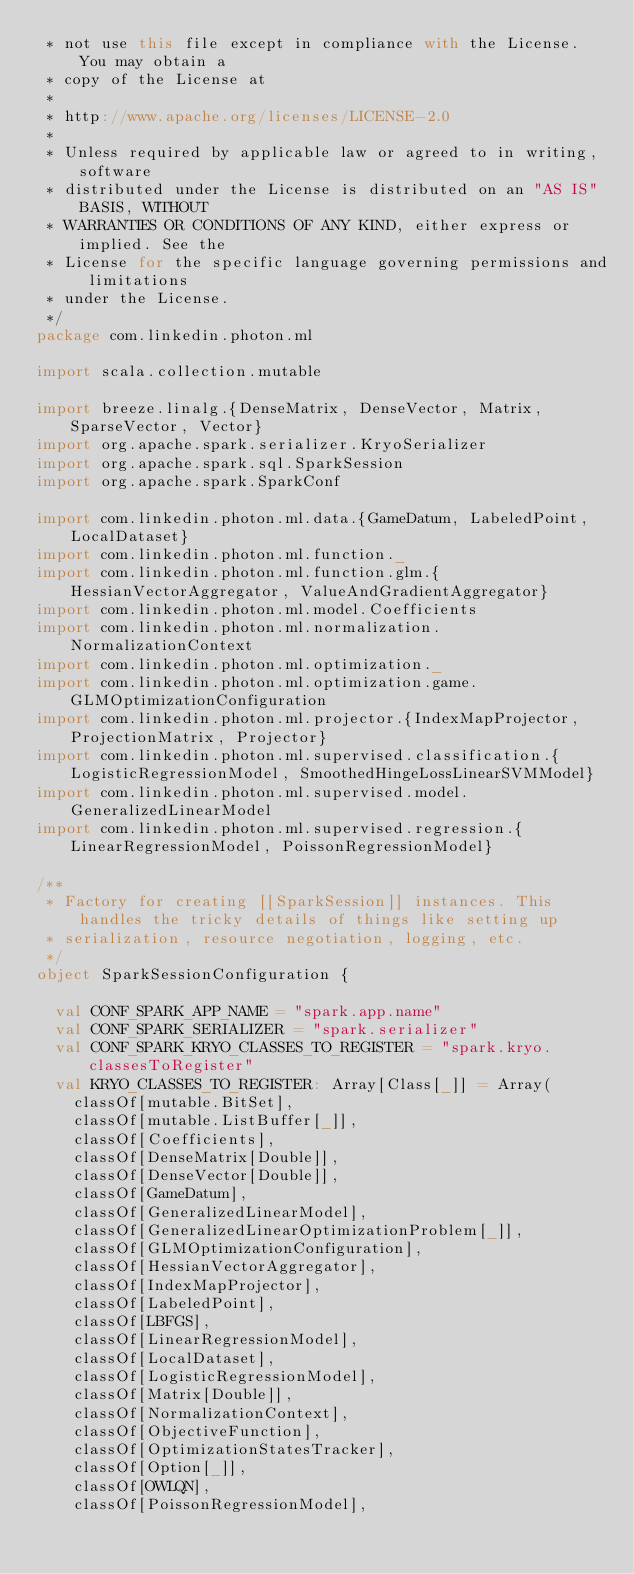<code> <loc_0><loc_0><loc_500><loc_500><_Scala_> * not use this file except in compliance with the License. You may obtain a
 * copy of the License at
 *
 * http://www.apache.org/licenses/LICENSE-2.0
 *
 * Unless required by applicable law or agreed to in writing, software
 * distributed under the License is distributed on an "AS IS" BASIS, WITHOUT
 * WARRANTIES OR CONDITIONS OF ANY KIND, either express or implied. See the
 * License for the specific language governing permissions and limitations
 * under the License.
 */
package com.linkedin.photon.ml

import scala.collection.mutable

import breeze.linalg.{DenseMatrix, DenseVector, Matrix, SparseVector, Vector}
import org.apache.spark.serializer.KryoSerializer
import org.apache.spark.sql.SparkSession
import org.apache.spark.SparkConf

import com.linkedin.photon.ml.data.{GameDatum, LabeledPoint, LocalDataset}
import com.linkedin.photon.ml.function._
import com.linkedin.photon.ml.function.glm.{HessianVectorAggregator, ValueAndGradientAggregator}
import com.linkedin.photon.ml.model.Coefficients
import com.linkedin.photon.ml.normalization.NormalizationContext
import com.linkedin.photon.ml.optimization._
import com.linkedin.photon.ml.optimization.game.GLMOptimizationConfiguration
import com.linkedin.photon.ml.projector.{IndexMapProjector, ProjectionMatrix, Projector}
import com.linkedin.photon.ml.supervised.classification.{LogisticRegressionModel, SmoothedHingeLossLinearSVMModel}
import com.linkedin.photon.ml.supervised.model.GeneralizedLinearModel
import com.linkedin.photon.ml.supervised.regression.{LinearRegressionModel, PoissonRegressionModel}

/**
 * Factory for creating [[SparkSession]] instances. This handles the tricky details of things like setting up
 * serialization, resource negotiation, logging, etc.
 */
object SparkSessionConfiguration {

  val CONF_SPARK_APP_NAME = "spark.app.name"
  val CONF_SPARK_SERIALIZER = "spark.serializer"
  val CONF_SPARK_KRYO_CLASSES_TO_REGISTER = "spark.kryo.classesToRegister"
  val KRYO_CLASSES_TO_REGISTER: Array[Class[_]] = Array(
    classOf[mutable.BitSet],
    classOf[mutable.ListBuffer[_]],
    classOf[Coefficients],
    classOf[DenseMatrix[Double]],
    classOf[DenseVector[Double]],
    classOf[GameDatum],
    classOf[GeneralizedLinearModel],
    classOf[GeneralizedLinearOptimizationProblem[_]],
    classOf[GLMOptimizationConfiguration],
    classOf[HessianVectorAggregator],
    classOf[IndexMapProjector],
    classOf[LabeledPoint],
    classOf[LBFGS],
    classOf[LinearRegressionModel],
    classOf[LocalDataset],
    classOf[LogisticRegressionModel],
    classOf[Matrix[Double]],
    classOf[NormalizationContext],
    classOf[ObjectiveFunction],
    classOf[OptimizationStatesTracker],
    classOf[Option[_]],
    classOf[OWLQN],
    classOf[PoissonRegressionModel],</code> 